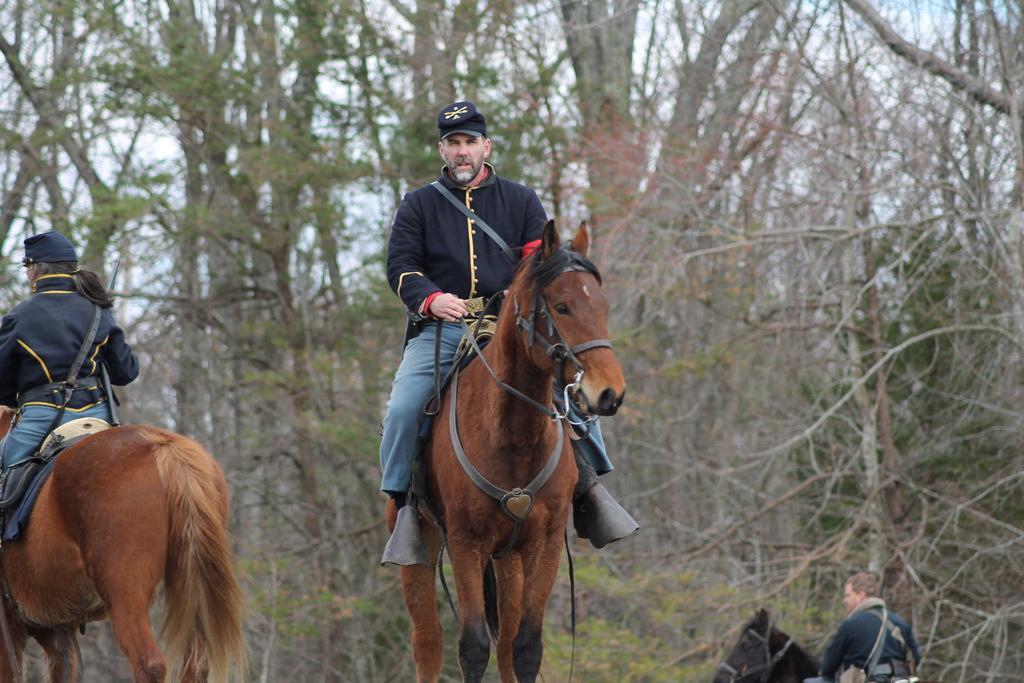Could you give a brief overview of what you see in this image? In this image we can see a few people riding the horses, there are some trees and also we can see the sky. 